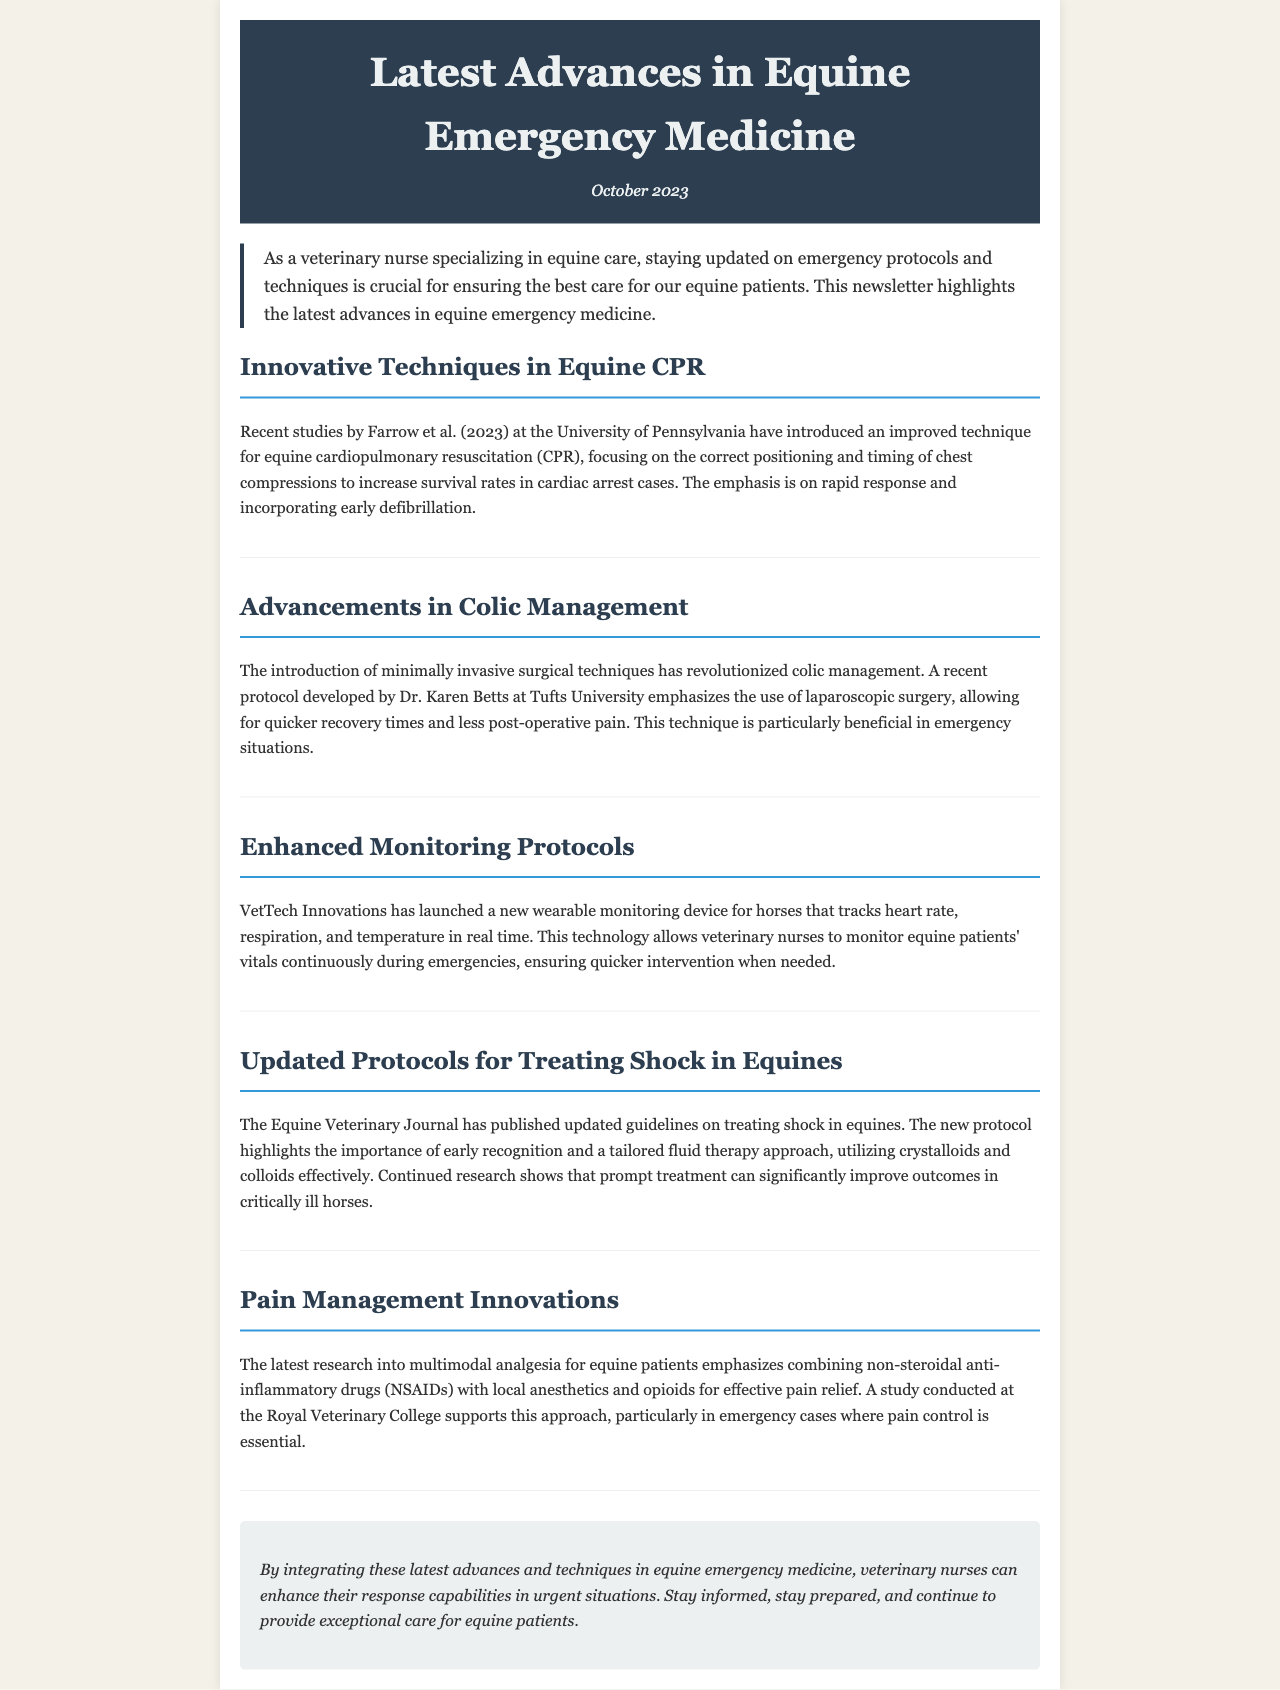What new technique for equine CPR is mentioned? The newsletter highlights an improved technique for equine cardiopulmonary resuscitation (CPR) focusing on correct positioning and timing of chest compressions.
Answer: Improved technique for equine CPR Who developed the new protocol for colic management? The newsletter states that Dr. Karen Betts at Tufts University developed a new protocol emphasizing laparoscopic surgery for colic management.
Answer: Dr. Karen Betts What is one benefit of using laparoscopic surgery in colic cases? The document mentions quicker recovery times and less post-operative pain as benefits of using laparoscopic surgery in emergency situations.
Answer: Quicker recovery times What does the new wearable monitoring device track? The device tracks heart rate, respiration, and temperature in real time during emergencies, according to the newsletter.
Answer: Heart rate, respiration, and temperature What is emphasized in the updated shock treatment protocol for equines? The newsletter states that the updated protocol highlights the importance of early recognition and a tailored fluid therapy approach.
Answer: Early recognition What approach is supported by the latest research in pain management? Multimodal analgesia, combining non-steroidal anti-inflammatory drugs with local anesthetics and opioids, is emphasized in the document.
Answer: Multimodal analgesia What is the primary focus of the newsletter? The primary focus of the newsletter is on the latest advances in equine emergency medicine.
Answer: Latest advances in equine emergency medicine When was the newsletter published? The date mentioned in the newsletter for publication is October 2023.
Answer: October 2023 